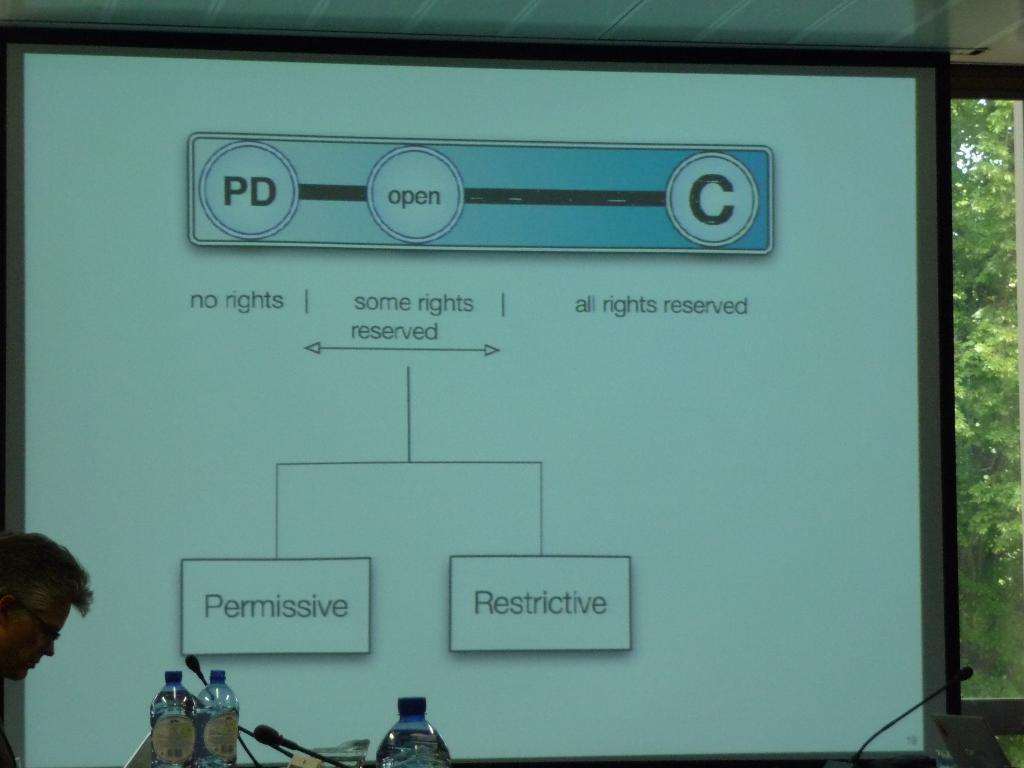Could you give a brief overview of what you see in this image? there are 3 plastic water bottles and microphones. at the left a person is standing and watching laptop. at the back there is a projector display. behind that there are trees. 